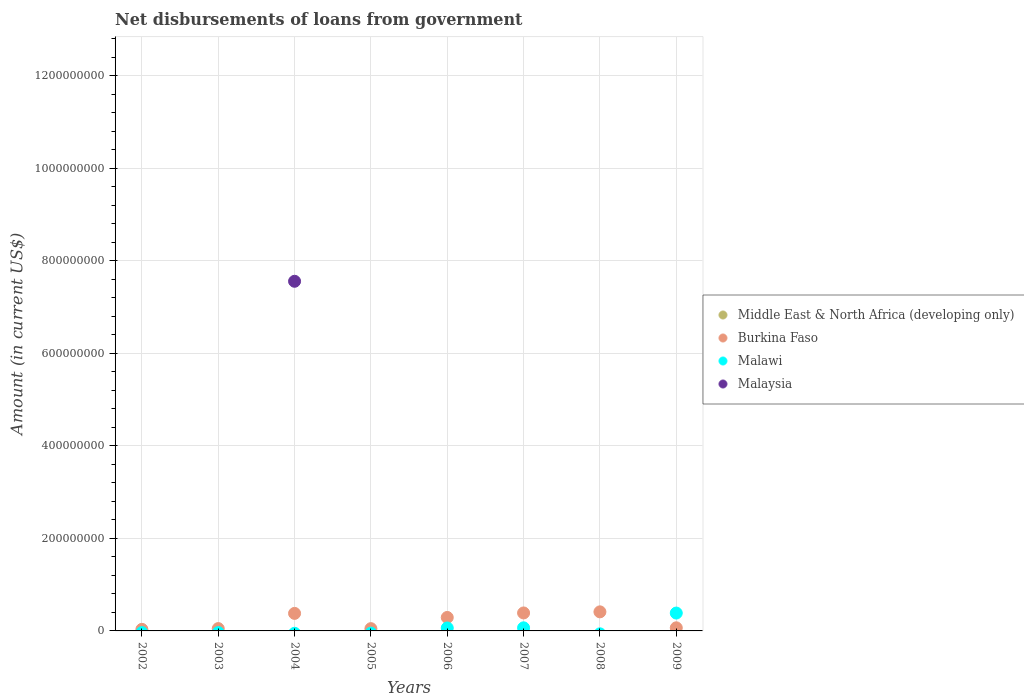How many different coloured dotlines are there?
Give a very brief answer. 3. What is the amount of loan disbursed from government in Malaysia in 2004?
Make the answer very short. 7.55e+08. Across all years, what is the maximum amount of loan disbursed from government in Malawi?
Provide a short and direct response. 3.86e+07. Across all years, what is the minimum amount of loan disbursed from government in Malaysia?
Offer a terse response. 0. In which year was the amount of loan disbursed from government in Malawi maximum?
Provide a succinct answer. 2009. What is the total amount of loan disbursed from government in Malawi in the graph?
Keep it short and to the point. 5.16e+07. What is the difference between the amount of loan disbursed from government in Burkina Faso in 2005 and that in 2009?
Provide a succinct answer. -1.78e+06. What is the difference between the amount of loan disbursed from government in Middle East & North Africa (developing only) in 2007 and the amount of loan disbursed from government in Malawi in 2008?
Offer a very short reply. 0. In the year 2009, what is the difference between the amount of loan disbursed from government in Burkina Faso and amount of loan disbursed from government in Malawi?
Make the answer very short. -3.19e+07. In how many years, is the amount of loan disbursed from government in Middle East & North Africa (developing only) greater than 1120000000 US$?
Your answer should be very brief. 0. What is the ratio of the amount of loan disbursed from government in Burkina Faso in 2002 to that in 2009?
Provide a succinct answer. 0.51. Is the amount of loan disbursed from government in Burkina Faso in 2003 less than that in 2008?
Offer a terse response. Yes. What is the difference between the highest and the second highest amount of loan disbursed from government in Malawi?
Your answer should be very brief. 3.19e+07. What is the difference between the highest and the lowest amount of loan disbursed from government in Malaysia?
Offer a very short reply. 7.55e+08. Does the amount of loan disbursed from government in Malawi monotonically increase over the years?
Your answer should be very brief. No. Is the amount of loan disbursed from government in Middle East & North Africa (developing only) strictly greater than the amount of loan disbursed from government in Malawi over the years?
Offer a very short reply. No. Is the amount of loan disbursed from government in Burkina Faso strictly less than the amount of loan disbursed from government in Middle East & North Africa (developing only) over the years?
Offer a very short reply. No. How many dotlines are there?
Give a very brief answer. 3. Are the values on the major ticks of Y-axis written in scientific E-notation?
Provide a short and direct response. No. Where does the legend appear in the graph?
Offer a terse response. Center right. How are the legend labels stacked?
Your response must be concise. Vertical. What is the title of the graph?
Offer a very short reply. Net disbursements of loans from government. Does "East Asia (developing only)" appear as one of the legend labels in the graph?
Your answer should be very brief. No. What is the Amount (in current US$) in Middle East & North Africa (developing only) in 2002?
Offer a very short reply. 0. What is the Amount (in current US$) of Burkina Faso in 2002?
Ensure brevity in your answer.  3.39e+06. What is the Amount (in current US$) of Malawi in 2002?
Give a very brief answer. 0. What is the Amount (in current US$) of Malaysia in 2002?
Provide a short and direct response. 0. What is the Amount (in current US$) in Burkina Faso in 2003?
Ensure brevity in your answer.  5.03e+06. What is the Amount (in current US$) of Malaysia in 2003?
Give a very brief answer. 0. What is the Amount (in current US$) in Middle East & North Africa (developing only) in 2004?
Your answer should be very brief. 0. What is the Amount (in current US$) of Burkina Faso in 2004?
Your response must be concise. 3.79e+07. What is the Amount (in current US$) in Malawi in 2004?
Offer a very short reply. 0. What is the Amount (in current US$) of Malaysia in 2004?
Your response must be concise. 7.55e+08. What is the Amount (in current US$) of Burkina Faso in 2005?
Your response must be concise. 4.92e+06. What is the Amount (in current US$) of Malawi in 2005?
Ensure brevity in your answer.  0. What is the Amount (in current US$) of Malaysia in 2005?
Ensure brevity in your answer.  0. What is the Amount (in current US$) in Middle East & North Africa (developing only) in 2006?
Give a very brief answer. 0. What is the Amount (in current US$) in Burkina Faso in 2006?
Give a very brief answer. 2.91e+07. What is the Amount (in current US$) of Malawi in 2006?
Keep it short and to the point. 6.36e+06. What is the Amount (in current US$) in Burkina Faso in 2007?
Your response must be concise. 3.88e+07. What is the Amount (in current US$) in Malawi in 2007?
Your answer should be compact. 6.68e+06. What is the Amount (in current US$) of Burkina Faso in 2008?
Make the answer very short. 4.12e+07. What is the Amount (in current US$) in Malaysia in 2008?
Ensure brevity in your answer.  0. What is the Amount (in current US$) in Burkina Faso in 2009?
Ensure brevity in your answer.  6.70e+06. What is the Amount (in current US$) of Malawi in 2009?
Offer a terse response. 3.86e+07. Across all years, what is the maximum Amount (in current US$) in Burkina Faso?
Provide a succinct answer. 4.12e+07. Across all years, what is the maximum Amount (in current US$) of Malawi?
Give a very brief answer. 3.86e+07. Across all years, what is the maximum Amount (in current US$) of Malaysia?
Your answer should be compact. 7.55e+08. Across all years, what is the minimum Amount (in current US$) in Burkina Faso?
Provide a short and direct response. 3.39e+06. Across all years, what is the minimum Amount (in current US$) of Malaysia?
Provide a short and direct response. 0. What is the total Amount (in current US$) in Burkina Faso in the graph?
Provide a short and direct response. 1.67e+08. What is the total Amount (in current US$) in Malawi in the graph?
Your response must be concise. 5.16e+07. What is the total Amount (in current US$) of Malaysia in the graph?
Offer a terse response. 7.55e+08. What is the difference between the Amount (in current US$) in Burkina Faso in 2002 and that in 2003?
Your response must be concise. -1.64e+06. What is the difference between the Amount (in current US$) in Burkina Faso in 2002 and that in 2004?
Offer a very short reply. -3.45e+07. What is the difference between the Amount (in current US$) of Burkina Faso in 2002 and that in 2005?
Offer a terse response. -1.53e+06. What is the difference between the Amount (in current US$) of Burkina Faso in 2002 and that in 2006?
Ensure brevity in your answer.  -2.57e+07. What is the difference between the Amount (in current US$) in Burkina Faso in 2002 and that in 2007?
Your response must be concise. -3.54e+07. What is the difference between the Amount (in current US$) of Burkina Faso in 2002 and that in 2008?
Your answer should be very brief. -3.78e+07. What is the difference between the Amount (in current US$) of Burkina Faso in 2002 and that in 2009?
Offer a terse response. -3.31e+06. What is the difference between the Amount (in current US$) in Burkina Faso in 2003 and that in 2004?
Give a very brief answer. -3.28e+07. What is the difference between the Amount (in current US$) in Burkina Faso in 2003 and that in 2005?
Make the answer very short. 1.08e+05. What is the difference between the Amount (in current US$) in Burkina Faso in 2003 and that in 2006?
Your answer should be compact. -2.41e+07. What is the difference between the Amount (in current US$) of Burkina Faso in 2003 and that in 2007?
Offer a terse response. -3.38e+07. What is the difference between the Amount (in current US$) in Burkina Faso in 2003 and that in 2008?
Offer a terse response. -3.62e+07. What is the difference between the Amount (in current US$) in Burkina Faso in 2003 and that in 2009?
Ensure brevity in your answer.  -1.67e+06. What is the difference between the Amount (in current US$) in Burkina Faso in 2004 and that in 2005?
Offer a very short reply. 3.30e+07. What is the difference between the Amount (in current US$) of Burkina Faso in 2004 and that in 2006?
Provide a succinct answer. 8.79e+06. What is the difference between the Amount (in current US$) of Burkina Faso in 2004 and that in 2007?
Your answer should be compact. -9.55e+05. What is the difference between the Amount (in current US$) of Burkina Faso in 2004 and that in 2008?
Provide a succinct answer. -3.32e+06. What is the difference between the Amount (in current US$) of Burkina Faso in 2004 and that in 2009?
Your answer should be compact. 3.12e+07. What is the difference between the Amount (in current US$) of Burkina Faso in 2005 and that in 2006?
Provide a succinct answer. -2.42e+07. What is the difference between the Amount (in current US$) of Burkina Faso in 2005 and that in 2007?
Provide a short and direct response. -3.39e+07. What is the difference between the Amount (in current US$) of Burkina Faso in 2005 and that in 2008?
Keep it short and to the point. -3.63e+07. What is the difference between the Amount (in current US$) of Burkina Faso in 2005 and that in 2009?
Ensure brevity in your answer.  -1.78e+06. What is the difference between the Amount (in current US$) of Burkina Faso in 2006 and that in 2007?
Give a very brief answer. -9.75e+06. What is the difference between the Amount (in current US$) in Malawi in 2006 and that in 2007?
Make the answer very short. -3.26e+05. What is the difference between the Amount (in current US$) of Burkina Faso in 2006 and that in 2008?
Give a very brief answer. -1.21e+07. What is the difference between the Amount (in current US$) of Burkina Faso in 2006 and that in 2009?
Offer a terse response. 2.24e+07. What is the difference between the Amount (in current US$) of Malawi in 2006 and that in 2009?
Offer a terse response. -3.22e+07. What is the difference between the Amount (in current US$) in Burkina Faso in 2007 and that in 2008?
Your answer should be very brief. -2.37e+06. What is the difference between the Amount (in current US$) of Burkina Faso in 2007 and that in 2009?
Your answer should be very brief. 3.21e+07. What is the difference between the Amount (in current US$) of Malawi in 2007 and that in 2009?
Provide a short and direct response. -3.19e+07. What is the difference between the Amount (in current US$) in Burkina Faso in 2008 and that in 2009?
Provide a short and direct response. 3.45e+07. What is the difference between the Amount (in current US$) in Burkina Faso in 2002 and the Amount (in current US$) in Malaysia in 2004?
Ensure brevity in your answer.  -7.52e+08. What is the difference between the Amount (in current US$) in Burkina Faso in 2002 and the Amount (in current US$) in Malawi in 2006?
Your answer should be compact. -2.97e+06. What is the difference between the Amount (in current US$) in Burkina Faso in 2002 and the Amount (in current US$) in Malawi in 2007?
Provide a succinct answer. -3.30e+06. What is the difference between the Amount (in current US$) in Burkina Faso in 2002 and the Amount (in current US$) in Malawi in 2009?
Offer a terse response. -3.52e+07. What is the difference between the Amount (in current US$) of Burkina Faso in 2003 and the Amount (in current US$) of Malaysia in 2004?
Give a very brief answer. -7.50e+08. What is the difference between the Amount (in current US$) of Burkina Faso in 2003 and the Amount (in current US$) of Malawi in 2006?
Offer a very short reply. -1.33e+06. What is the difference between the Amount (in current US$) in Burkina Faso in 2003 and the Amount (in current US$) in Malawi in 2007?
Your answer should be compact. -1.66e+06. What is the difference between the Amount (in current US$) of Burkina Faso in 2003 and the Amount (in current US$) of Malawi in 2009?
Give a very brief answer. -3.36e+07. What is the difference between the Amount (in current US$) in Burkina Faso in 2004 and the Amount (in current US$) in Malawi in 2006?
Your response must be concise. 3.15e+07. What is the difference between the Amount (in current US$) of Burkina Faso in 2004 and the Amount (in current US$) of Malawi in 2007?
Give a very brief answer. 3.12e+07. What is the difference between the Amount (in current US$) in Burkina Faso in 2004 and the Amount (in current US$) in Malawi in 2009?
Your response must be concise. -7.21e+05. What is the difference between the Amount (in current US$) of Burkina Faso in 2005 and the Amount (in current US$) of Malawi in 2006?
Your answer should be very brief. -1.44e+06. What is the difference between the Amount (in current US$) of Burkina Faso in 2005 and the Amount (in current US$) of Malawi in 2007?
Ensure brevity in your answer.  -1.76e+06. What is the difference between the Amount (in current US$) in Burkina Faso in 2005 and the Amount (in current US$) in Malawi in 2009?
Your response must be concise. -3.37e+07. What is the difference between the Amount (in current US$) of Burkina Faso in 2006 and the Amount (in current US$) of Malawi in 2007?
Offer a very short reply. 2.24e+07. What is the difference between the Amount (in current US$) in Burkina Faso in 2006 and the Amount (in current US$) in Malawi in 2009?
Provide a succinct answer. -9.51e+06. What is the difference between the Amount (in current US$) in Burkina Faso in 2007 and the Amount (in current US$) in Malawi in 2009?
Make the answer very short. 2.34e+05. What is the difference between the Amount (in current US$) in Burkina Faso in 2008 and the Amount (in current US$) in Malawi in 2009?
Offer a terse response. 2.60e+06. What is the average Amount (in current US$) in Middle East & North Africa (developing only) per year?
Your response must be concise. 0. What is the average Amount (in current US$) of Burkina Faso per year?
Provide a short and direct response. 2.09e+07. What is the average Amount (in current US$) in Malawi per year?
Keep it short and to the point. 6.46e+06. What is the average Amount (in current US$) in Malaysia per year?
Offer a very short reply. 9.44e+07. In the year 2004, what is the difference between the Amount (in current US$) in Burkina Faso and Amount (in current US$) in Malaysia?
Give a very brief answer. -7.18e+08. In the year 2006, what is the difference between the Amount (in current US$) in Burkina Faso and Amount (in current US$) in Malawi?
Provide a succinct answer. 2.27e+07. In the year 2007, what is the difference between the Amount (in current US$) of Burkina Faso and Amount (in current US$) of Malawi?
Your answer should be very brief. 3.21e+07. In the year 2009, what is the difference between the Amount (in current US$) in Burkina Faso and Amount (in current US$) in Malawi?
Offer a very short reply. -3.19e+07. What is the ratio of the Amount (in current US$) of Burkina Faso in 2002 to that in 2003?
Give a very brief answer. 0.67. What is the ratio of the Amount (in current US$) of Burkina Faso in 2002 to that in 2004?
Offer a very short reply. 0.09. What is the ratio of the Amount (in current US$) in Burkina Faso in 2002 to that in 2005?
Ensure brevity in your answer.  0.69. What is the ratio of the Amount (in current US$) of Burkina Faso in 2002 to that in 2006?
Your answer should be compact. 0.12. What is the ratio of the Amount (in current US$) of Burkina Faso in 2002 to that in 2007?
Your answer should be very brief. 0.09. What is the ratio of the Amount (in current US$) in Burkina Faso in 2002 to that in 2008?
Offer a very short reply. 0.08. What is the ratio of the Amount (in current US$) in Burkina Faso in 2002 to that in 2009?
Give a very brief answer. 0.51. What is the ratio of the Amount (in current US$) in Burkina Faso in 2003 to that in 2004?
Provide a short and direct response. 0.13. What is the ratio of the Amount (in current US$) of Burkina Faso in 2003 to that in 2006?
Ensure brevity in your answer.  0.17. What is the ratio of the Amount (in current US$) in Burkina Faso in 2003 to that in 2007?
Your answer should be very brief. 0.13. What is the ratio of the Amount (in current US$) in Burkina Faso in 2003 to that in 2008?
Ensure brevity in your answer.  0.12. What is the ratio of the Amount (in current US$) in Burkina Faso in 2003 to that in 2009?
Your response must be concise. 0.75. What is the ratio of the Amount (in current US$) of Burkina Faso in 2004 to that in 2005?
Keep it short and to the point. 7.7. What is the ratio of the Amount (in current US$) in Burkina Faso in 2004 to that in 2006?
Keep it short and to the point. 1.3. What is the ratio of the Amount (in current US$) in Burkina Faso in 2004 to that in 2007?
Ensure brevity in your answer.  0.98. What is the ratio of the Amount (in current US$) of Burkina Faso in 2004 to that in 2008?
Your answer should be compact. 0.92. What is the ratio of the Amount (in current US$) of Burkina Faso in 2004 to that in 2009?
Give a very brief answer. 5.66. What is the ratio of the Amount (in current US$) of Burkina Faso in 2005 to that in 2006?
Your answer should be compact. 0.17. What is the ratio of the Amount (in current US$) of Burkina Faso in 2005 to that in 2007?
Keep it short and to the point. 0.13. What is the ratio of the Amount (in current US$) in Burkina Faso in 2005 to that in 2008?
Offer a very short reply. 0.12. What is the ratio of the Amount (in current US$) of Burkina Faso in 2005 to that in 2009?
Your answer should be very brief. 0.73. What is the ratio of the Amount (in current US$) in Burkina Faso in 2006 to that in 2007?
Offer a very short reply. 0.75. What is the ratio of the Amount (in current US$) of Malawi in 2006 to that in 2007?
Give a very brief answer. 0.95. What is the ratio of the Amount (in current US$) in Burkina Faso in 2006 to that in 2008?
Provide a short and direct response. 0.71. What is the ratio of the Amount (in current US$) of Burkina Faso in 2006 to that in 2009?
Your response must be concise. 4.34. What is the ratio of the Amount (in current US$) in Malawi in 2006 to that in 2009?
Offer a terse response. 0.16. What is the ratio of the Amount (in current US$) in Burkina Faso in 2007 to that in 2008?
Provide a succinct answer. 0.94. What is the ratio of the Amount (in current US$) in Burkina Faso in 2007 to that in 2009?
Provide a short and direct response. 5.8. What is the ratio of the Amount (in current US$) in Malawi in 2007 to that in 2009?
Your response must be concise. 0.17. What is the ratio of the Amount (in current US$) of Burkina Faso in 2008 to that in 2009?
Your answer should be compact. 6.15. What is the difference between the highest and the second highest Amount (in current US$) in Burkina Faso?
Your response must be concise. 2.37e+06. What is the difference between the highest and the second highest Amount (in current US$) of Malawi?
Your answer should be very brief. 3.19e+07. What is the difference between the highest and the lowest Amount (in current US$) of Burkina Faso?
Provide a short and direct response. 3.78e+07. What is the difference between the highest and the lowest Amount (in current US$) in Malawi?
Make the answer very short. 3.86e+07. What is the difference between the highest and the lowest Amount (in current US$) of Malaysia?
Offer a terse response. 7.55e+08. 